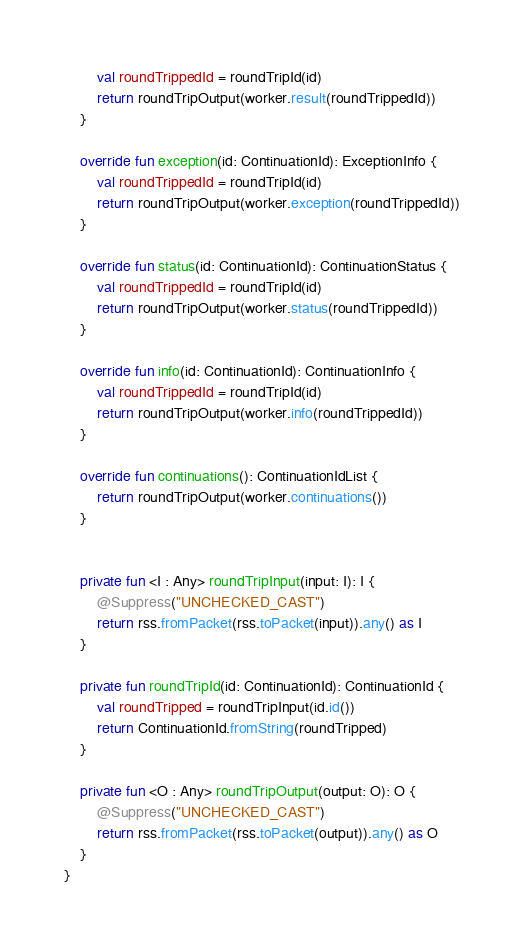<code> <loc_0><loc_0><loc_500><loc_500><_Kotlin_>        val roundTrippedId = roundTripId(id)
        return roundTripOutput(worker.result(roundTrippedId))
    }

    override fun exception(id: ContinuationId): ExceptionInfo {
        val roundTrippedId = roundTripId(id)
        return roundTripOutput(worker.exception(roundTrippedId))
    }

    override fun status(id: ContinuationId): ContinuationStatus {
        val roundTrippedId = roundTripId(id)
        return roundTripOutput(worker.status(roundTrippedId))
    }

    override fun info(id: ContinuationId): ContinuationInfo {
        val roundTrippedId = roundTripId(id)
        return roundTripOutput(worker.info(roundTrippedId))
    }

    override fun continuations(): ContinuationIdList {
        return roundTripOutput(worker.continuations())
    }


    private fun <I : Any> roundTripInput(input: I): I {
        @Suppress("UNCHECKED_CAST")
        return rss.fromPacket(rss.toPacket(input)).any() as I
    }

    private fun roundTripId(id: ContinuationId): ContinuationId {
        val roundTripped = roundTripInput(id.id())
        return ContinuationId.fromString(roundTripped)
    }

    private fun <O : Any> roundTripOutput(output: O): O {
        @Suppress("UNCHECKED_CAST")
        return rss.fromPacket(rss.toPacket(output)).any() as O
    }
}</code> 